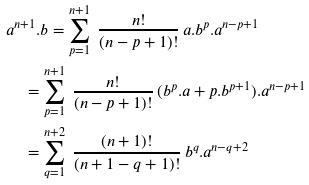<formula> <loc_0><loc_0><loc_500><loc_500>& a ^ { n + 1 } . b = \sum _ { p = 1 } ^ { n + 1 } \ \frac { n ! } { ( n - p + 1 ) ! } \, a . b ^ { p } . a ^ { n - p + 1 } \\ & \quad = \sum _ { p = 1 } ^ { n + 1 } \ \frac { n ! } { ( n - p + 1 ) ! } \, ( b ^ { p } . a + p . b ^ { p + 1 } ) . a ^ { n - p + 1 } \\ & \quad = \sum _ { q = 1 } ^ { n + 2 } \ \frac { ( n + 1 ) ! } { ( n + 1 - q + 1 ) ! } \, b ^ { q } . a ^ { n - q + 2 }</formula> 